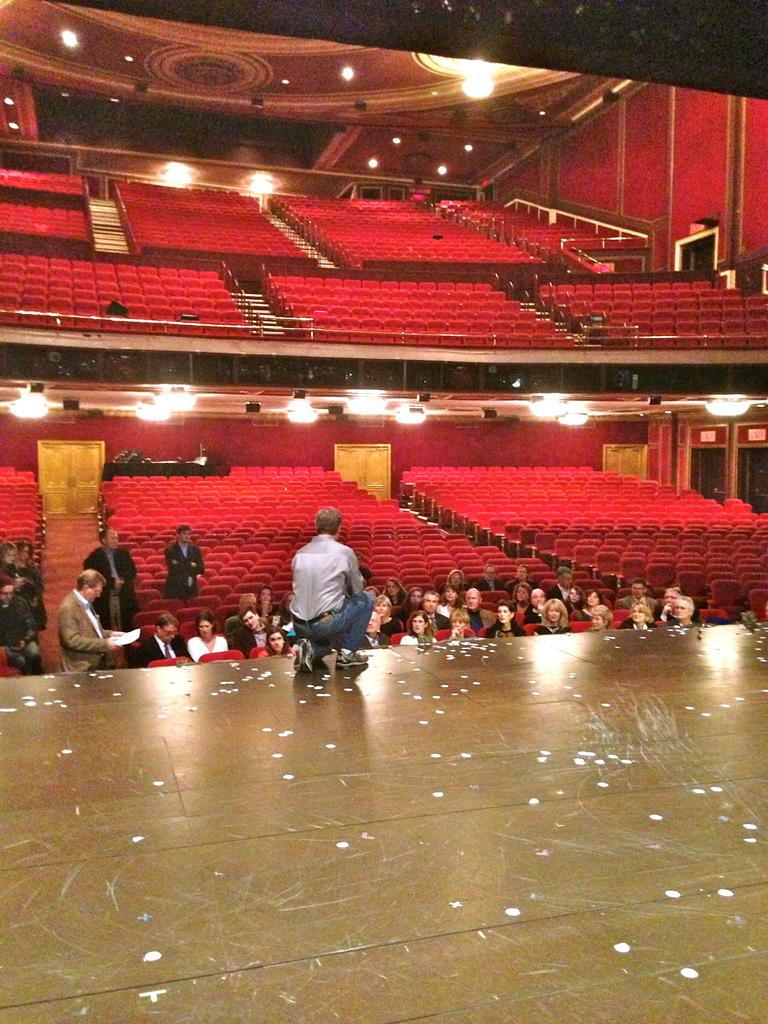What is the setting of the image? The people are in an auditorium. What are the people in the image doing? Some people are seated on chairs, and some are standing. What can be seen in the background of the image? There are lights and metal rods in the background. How many kittens are sitting on the dad's lap in the image? There are no kittens or a dad present in the image. 